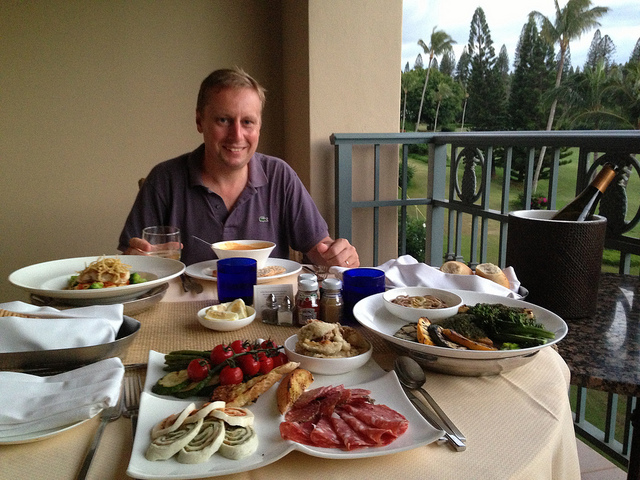What types of food are visible on the table? The table boasts a variety of foods including what looks like cold cuts, assorted vegetables like asparagus and cherry tomatoes, a basket with bread rolls, grilled prawns, pasta, and a platter with what could be cheeses or desserts. There's also a bottle of wine to complement the meal. It looks like an elaborate meal; is this a special occasion? While I can't confirm the occasion, the spread of food and the overall setting with elegant dinnerware and a champagne bottle hint at a celebration or perhaps a luxurious holiday meal, indicative of a special event. 